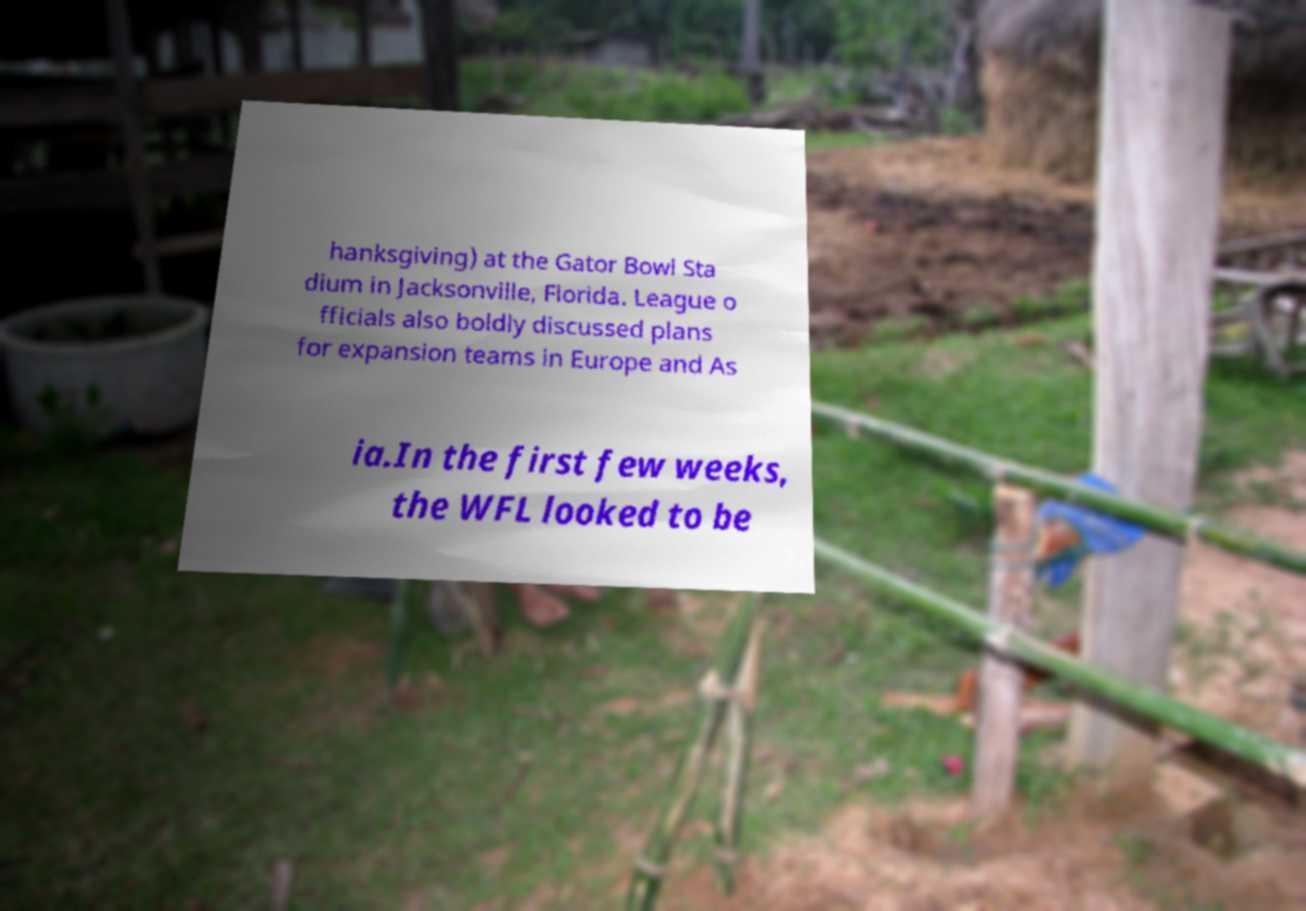Please read and relay the text visible in this image. What does it say? hanksgiving) at the Gator Bowl Sta dium in Jacksonville, Florida. League o fficials also boldly discussed plans for expansion teams in Europe and As ia.In the first few weeks, the WFL looked to be 